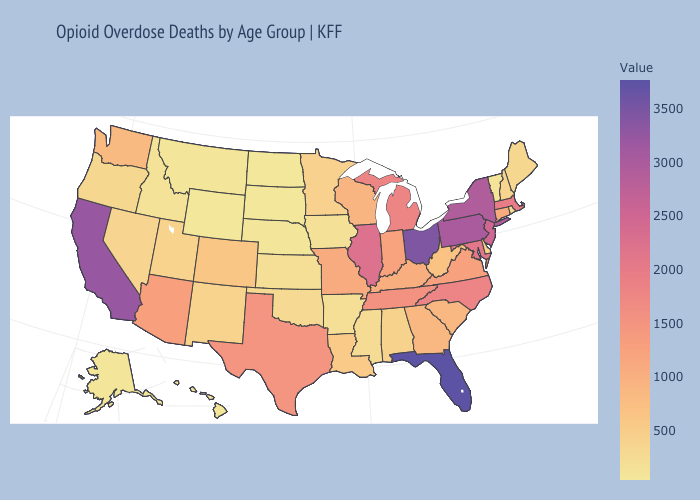Does Florida have a lower value than Virginia?
Write a very short answer. No. Among the states that border Delaware , which have the highest value?
Give a very brief answer. Pennsylvania. Among the states that border Mississippi , which have the lowest value?
Be succinct. Arkansas. Does South Dakota have the lowest value in the USA?
Keep it brief. Yes. Does Florida have the highest value in the South?
Short answer required. Yes. Which states have the highest value in the USA?
Concise answer only. Florida. 